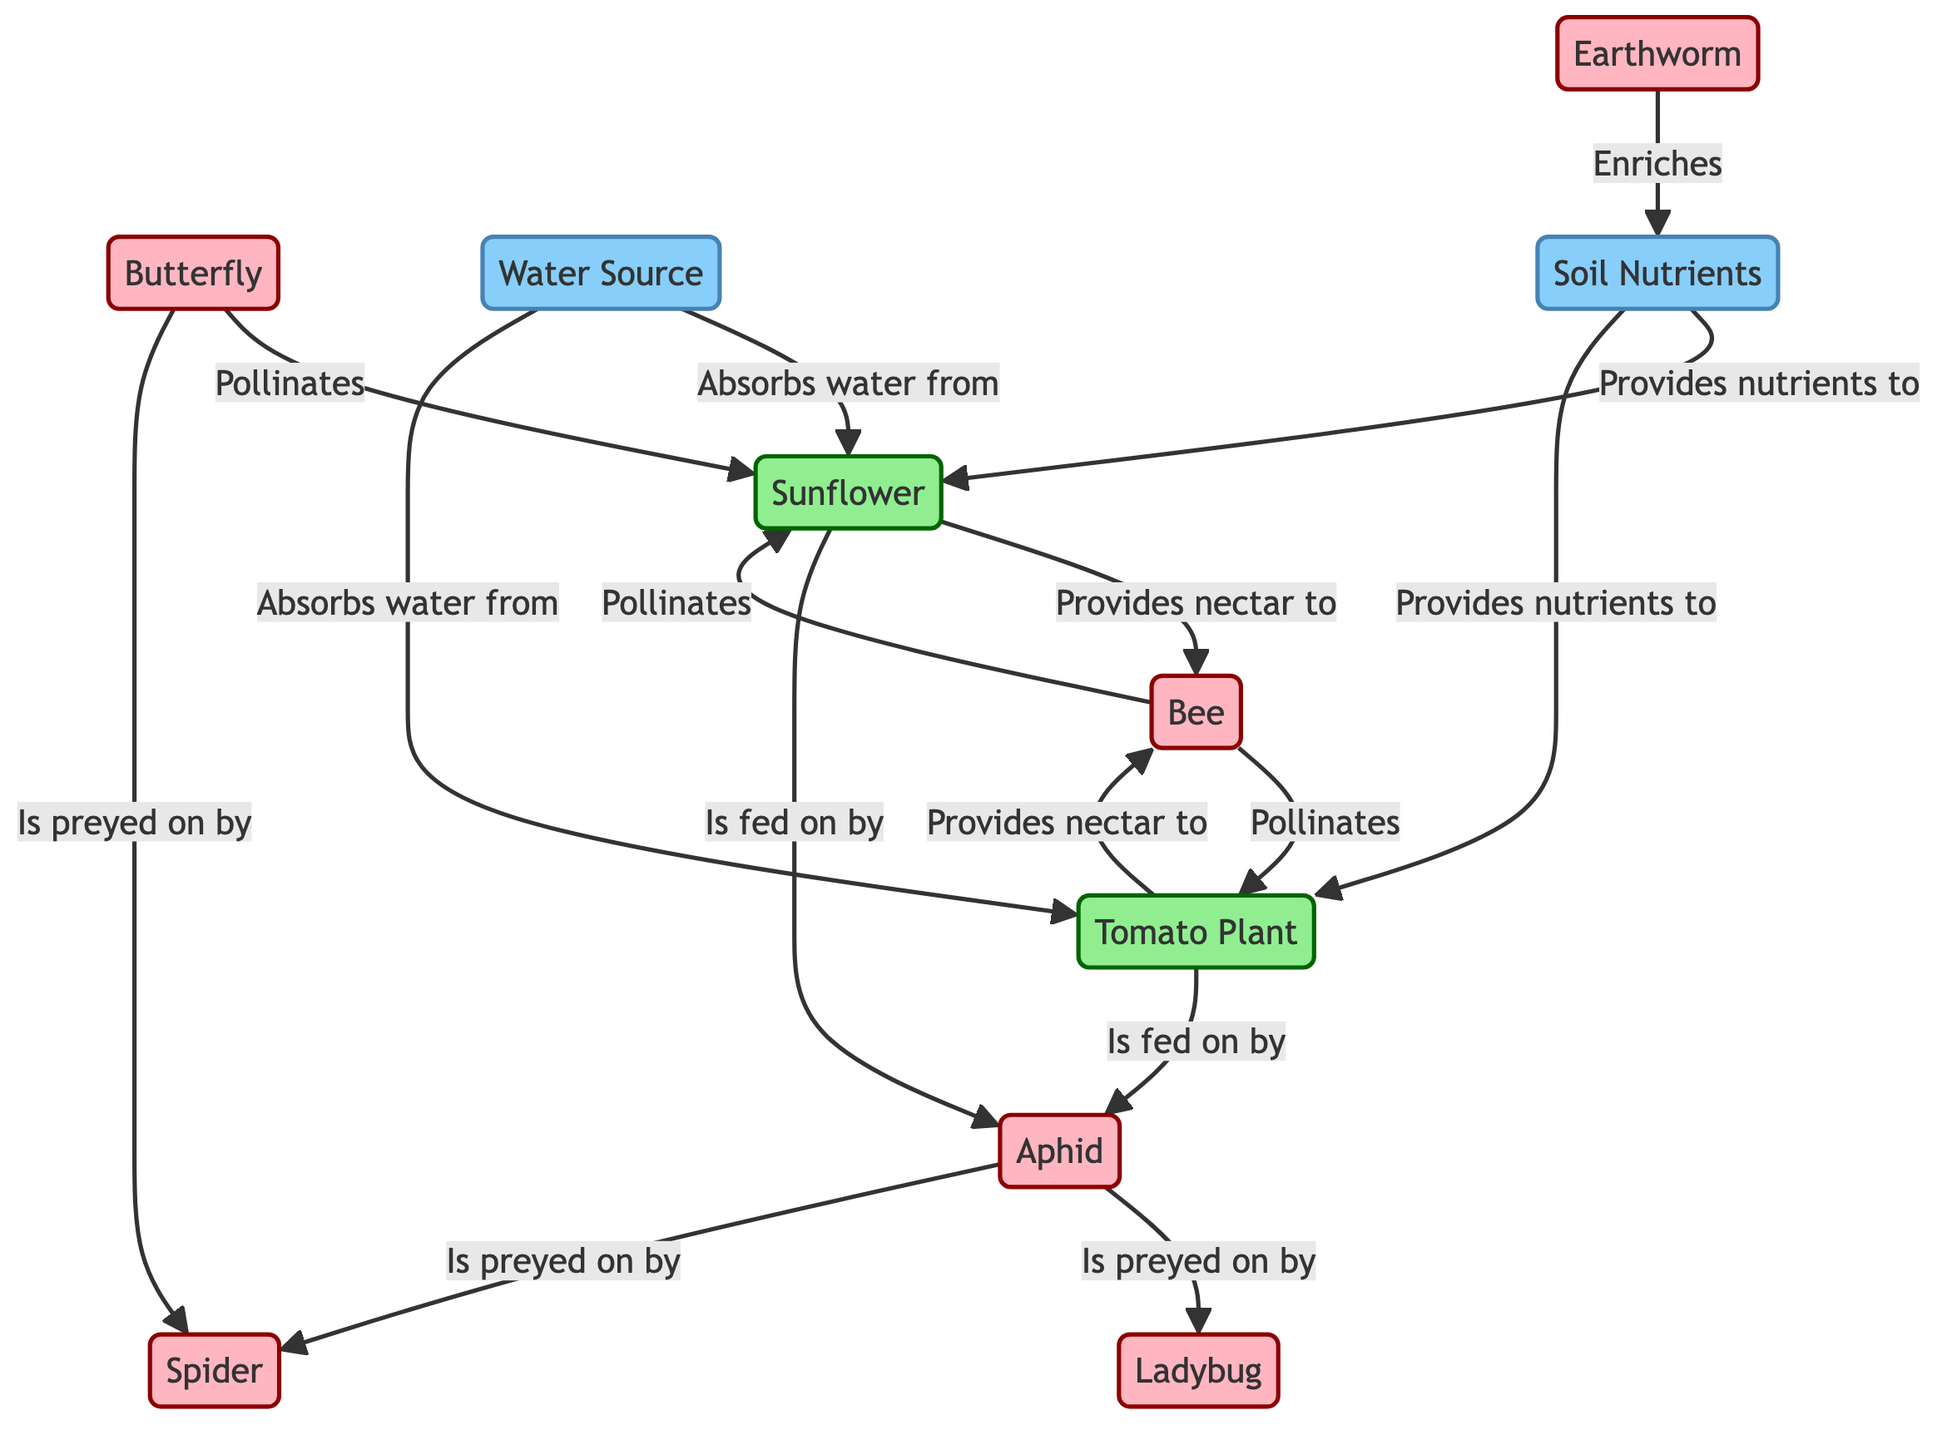What plant does the bee pollinate? According to the diagram, the bee is indicated to pollinate both the sunflower and the tomato plant.
Answer: sunflower, tomato plant How many animal species are involved in the ecosystem? The diagram shows six distinct animal species: bee, aphid, ladybug, butterfly, spider, and earthworm.
Answer: 6 Which plant is fed on by the aphid? The diagram specifies that the aphid feeds on both the sunflower and the tomato plant.
Answer: sunflower, tomato plant What resource enriches the soil? The diagram indicates that the earthworm enriches the soil.
Answer: earthworm What is the relationship between the ladybug and the aphid? As per the diagram, the ladybug preys on the aphid, establishing a predator-prey relationship.
Answer: preyed on by How does the soil contribute to the plants? The diagram states that the soil provides nutrients to both the sunflower and the tomato plant.
Answer: Provides nutrients Which animal is indicated as preying on the spider? The diagram does not show any animals preying on the spider; instead, it shows that the spider preys on the aphid and the butterfly. Thus, the focus remains on the spider as a predator.
Answer: None How many total pollination links are shown in the diagram? There are four distinct pollination links in the diagram: the bee pollinates the sunflower, the bee pollinates the tomato plant, and the butterfly also pollinates the sunflower.
Answer: 4 What two resources are critical for the plants? The resources indicated in the diagram that are critical for the plants are water source and soil nutrients.
Answer: water source, soil nutrients What is the function of water in relation to the plants? The diagram shows that water absorbs from both the sunflower and the tomato plant, indicating its role in taking up moisture from the plants.
Answer: Absorbs water from 